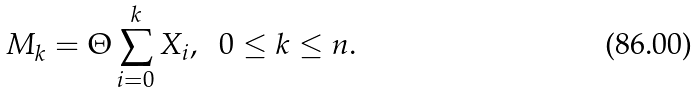<formula> <loc_0><loc_0><loc_500><loc_500>M _ { k } = { \Theta } \sum _ { i = 0 } ^ { k } X _ { i } , \ \ 0 \leq k \leq n .</formula> 